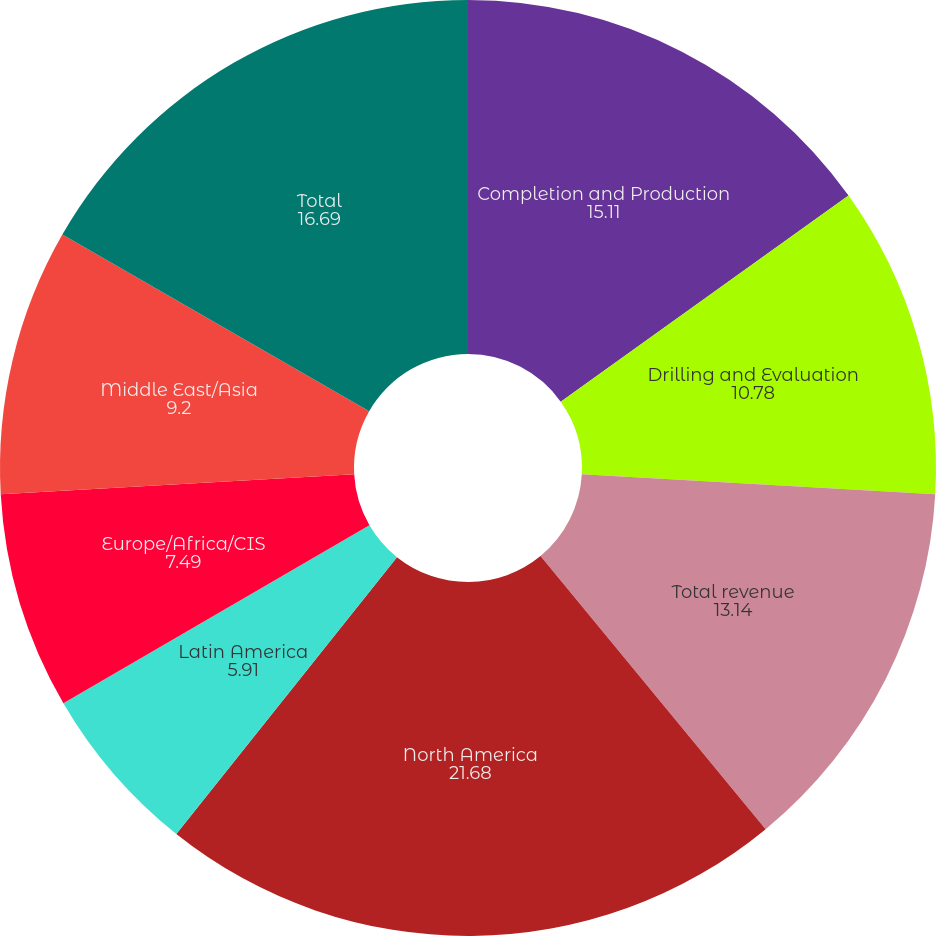Convert chart. <chart><loc_0><loc_0><loc_500><loc_500><pie_chart><fcel>Completion and Production<fcel>Drilling and Evaluation<fcel>Total revenue<fcel>North America<fcel>Latin America<fcel>Europe/Africa/CIS<fcel>Middle East/Asia<fcel>Total<nl><fcel>15.11%<fcel>10.78%<fcel>13.14%<fcel>21.68%<fcel>5.91%<fcel>7.49%<fcel>9.2%<fcel>16.69%<nl></chart> 